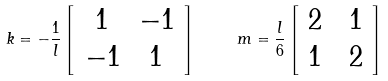<formula> <loc_0><loc_0><loc_500><loc_500>k = - \frac { 1 } { l } \left [ \begin{array} { c c } 1 & - 1 \\ - 1 & 1 \end{array} \right ] \quad \ m = \frac { l } { 6 } \left [ \begin{array} { c c } 2 \ & 1 \\ 1 \ & 2 \end{array} \right ]</formula> 